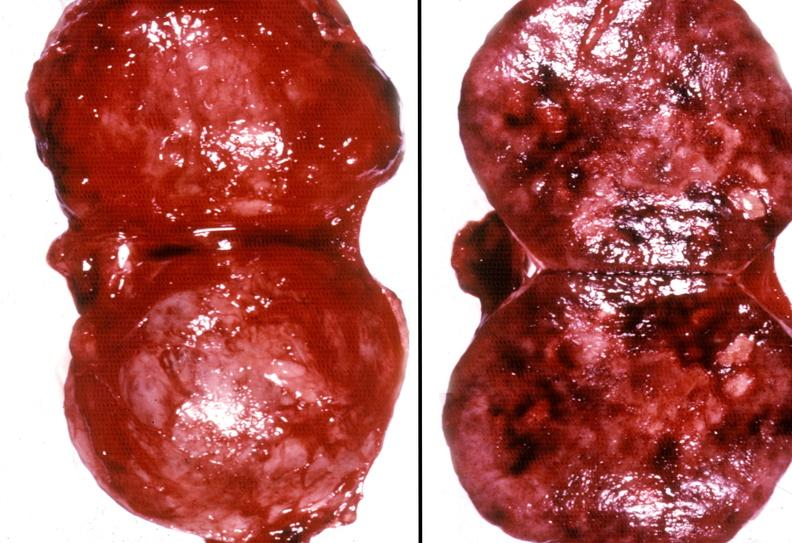s retroperitoneal liposarcoma present?
Answer the question using a single word or phrase. No 